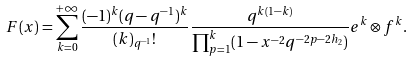Convert formula to latex. <formula><loc_0><loc_0><loc_500><loc_500>F ( x ) = \sum _ { k = 0 } ^ { + \infty } \frac { ( - 1 ) ^ { k } ( q - q ^ { - 1 } ) ^ { k } } { ( k ) _ { q ^ { - 1 } } ! } \frac { q ^ { k ( 1 - k ) } } { \prod _ { p = 1 } ^ { k } ( 1 - x ^ { - 2 } q ^ { - 2 p - 2 h _ { 2 } } ) } e ^ { k } \otimes f ^ { k } .</formula> 